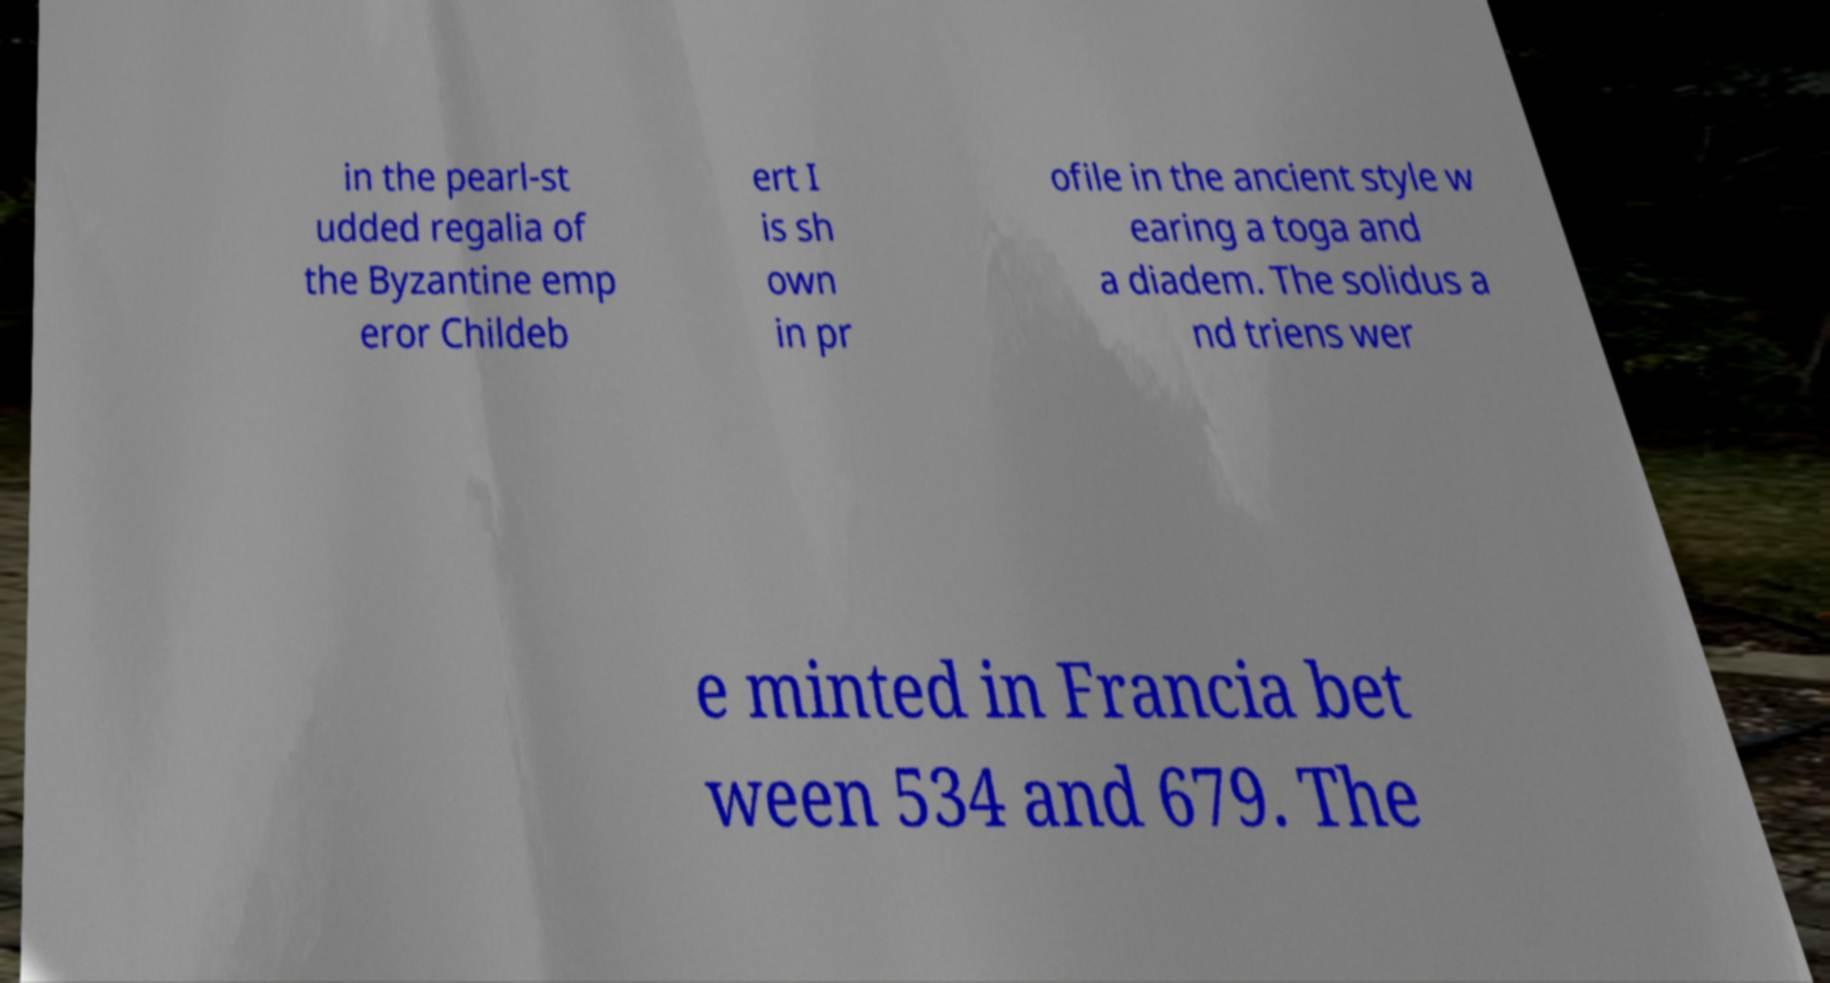Can you read and provide the text displayed in the image?This photo seems to have some interesting text. Can you extract and type it out for me? in the pearl-st udded regalia of the Byzantine emp eror Childeb ert I is sh own in pr ofile in the ancient style w earing a toga and a diadem. The solidus a nd triens wer e minted in Francia bet ween 534 and 679. The 